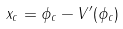<formula> <loc_0><loc_0><loc_500><loc_500>x _ { c } = \phi _ { c } - V ^ { \prime } ( \phi _ { c } )</formula> 